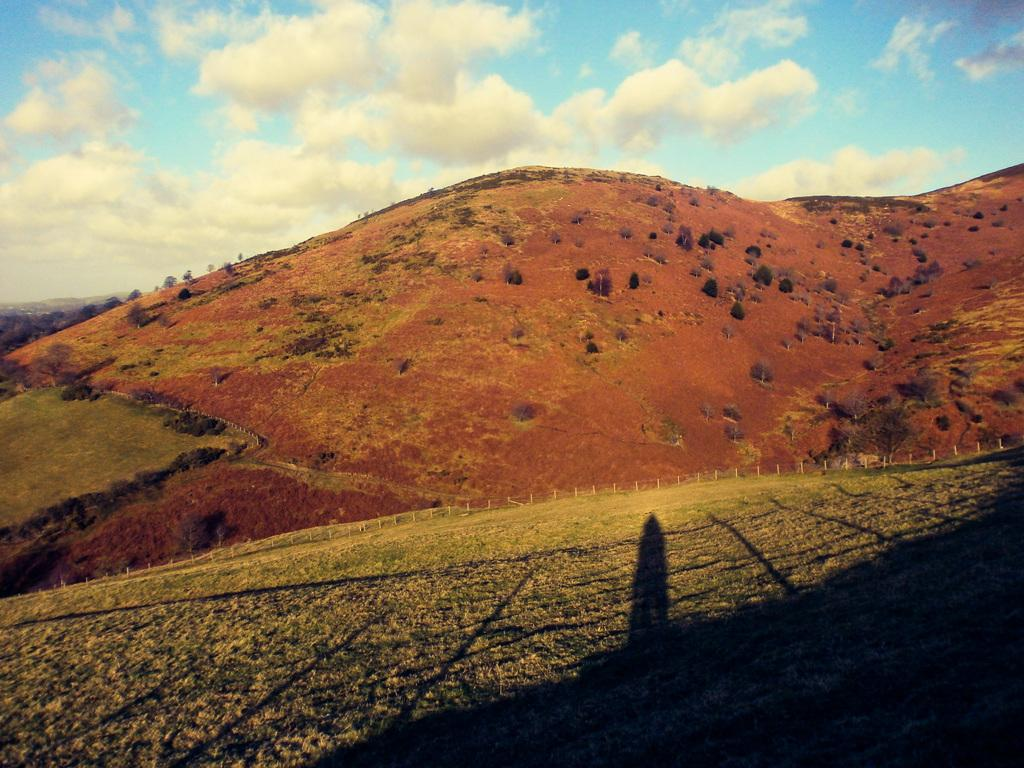What type of landscape feature is in the center of the image? There are hills in the center of the image. What type of vegetation is at the bottom of the image? There is grass at the bottom of the image. What type of barrier is visible in the image? There is a fence visible in the image. What can be seen in the background of the image? The sky is visible in the background of the image. Can you see a baby giraffe with a damaged nerve in the image? No, there is no baby giraffe or any reference to a damaged nerve in the image. 